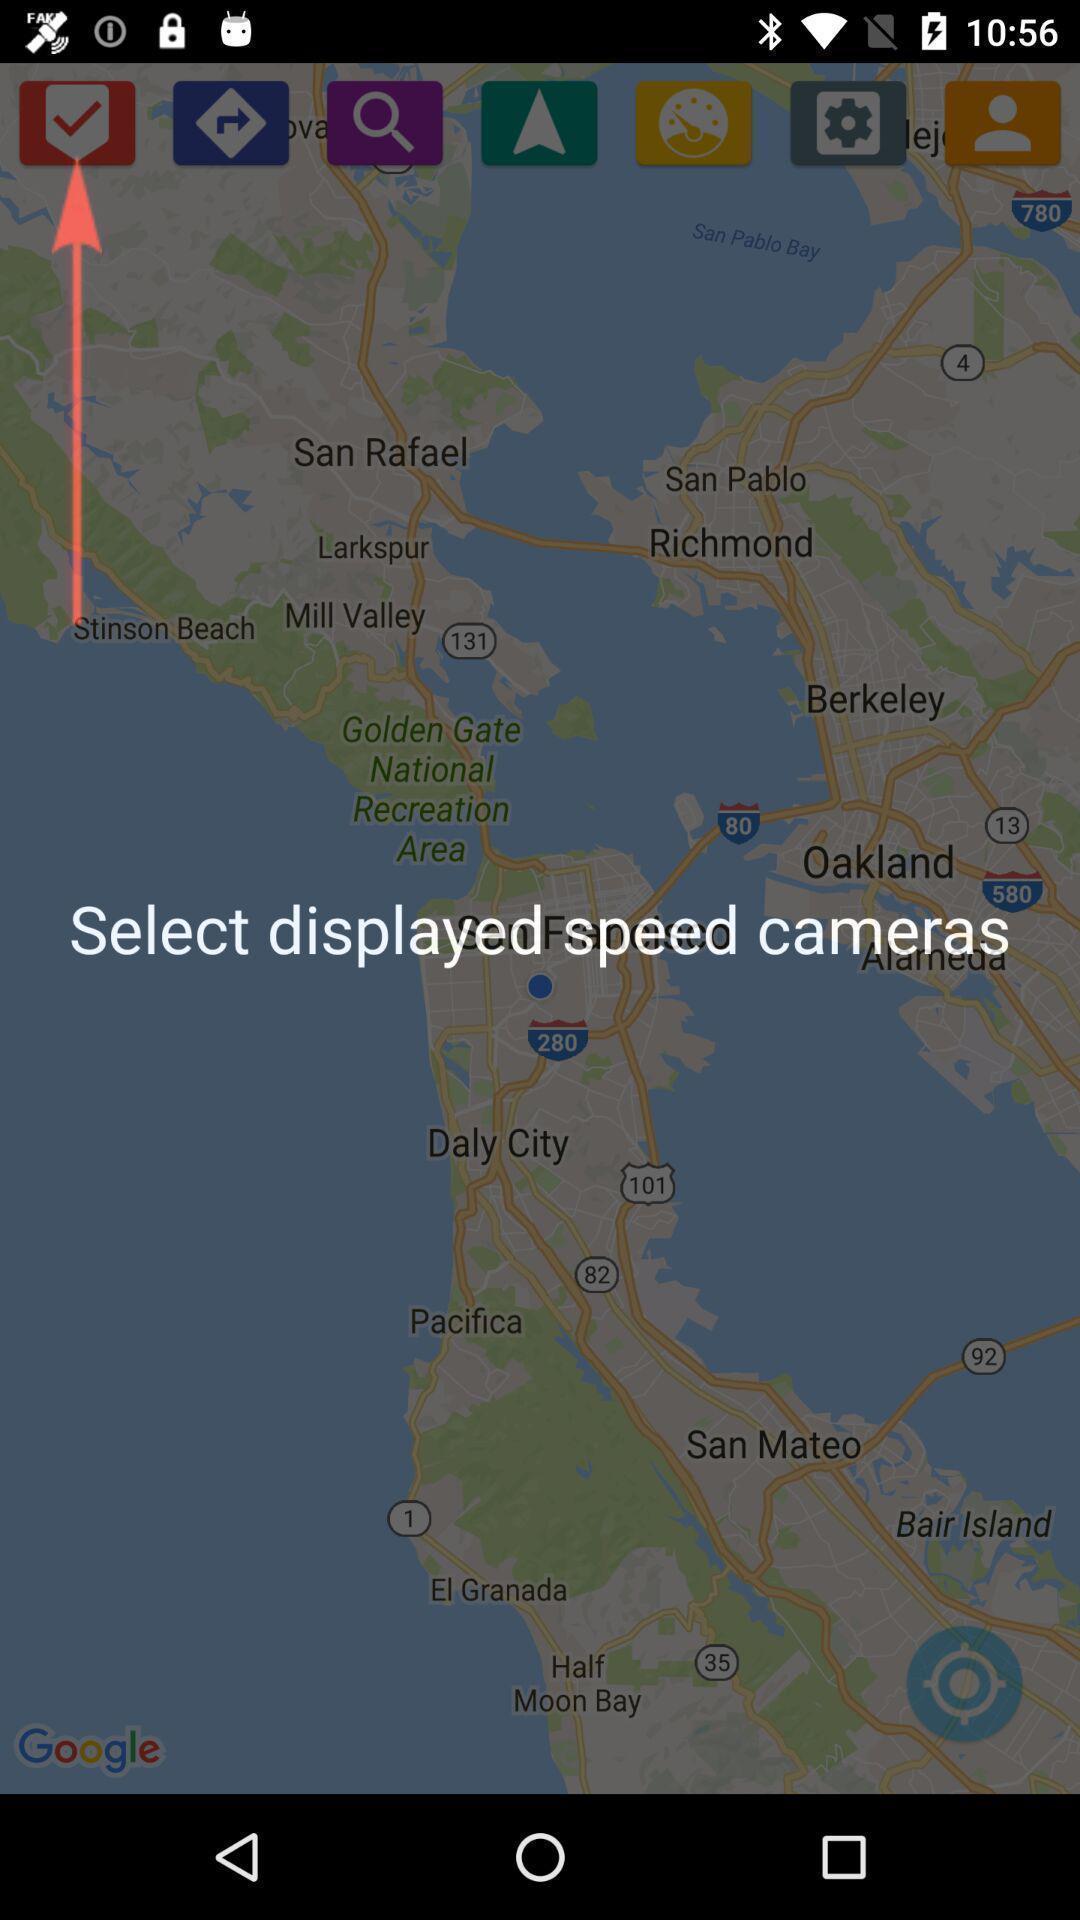What details can you identify in this image? Screen showing to select displayed speed cameras. 